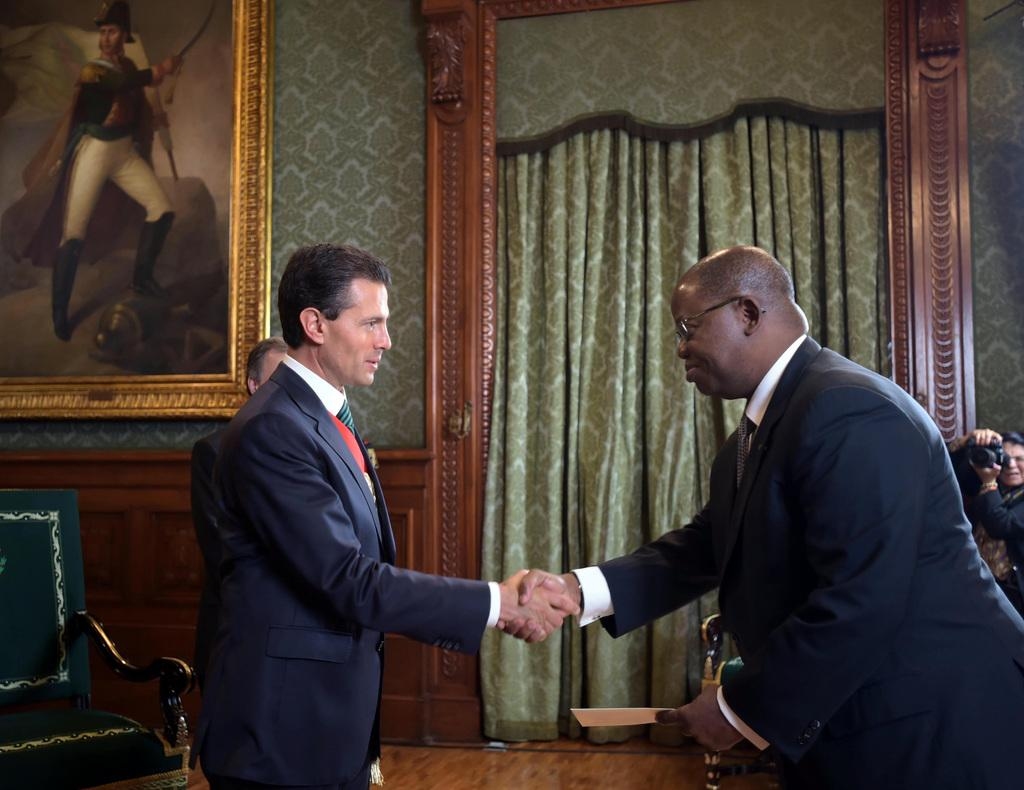How many people are in the image? There are two men in the image. What are the men doing in the image? The two men are standing and shaking hands together. What type of muscle can be seen in the image? There is no muscle visible in the image; it features two men shaking hands. Where is the nest located in the image? There is no nest present in the image. 